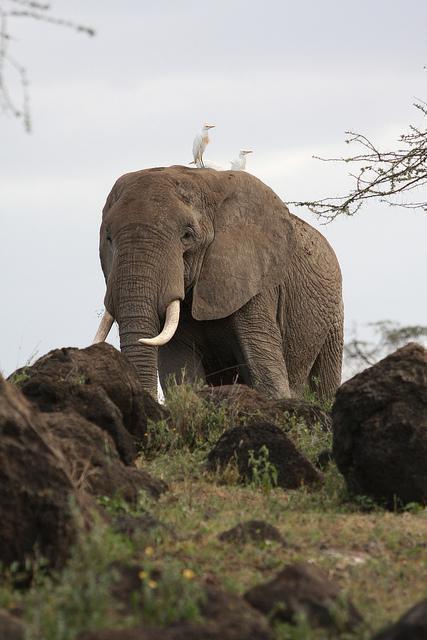What is in front of the elephant's tusks?
Make your selection and explain in format: 'Answer: answer
Rationale: rationale.'
Options: Rocks, branches, bark, grass. Answer: rocks.
Rationale: There are big boulders in front of the tusks. 